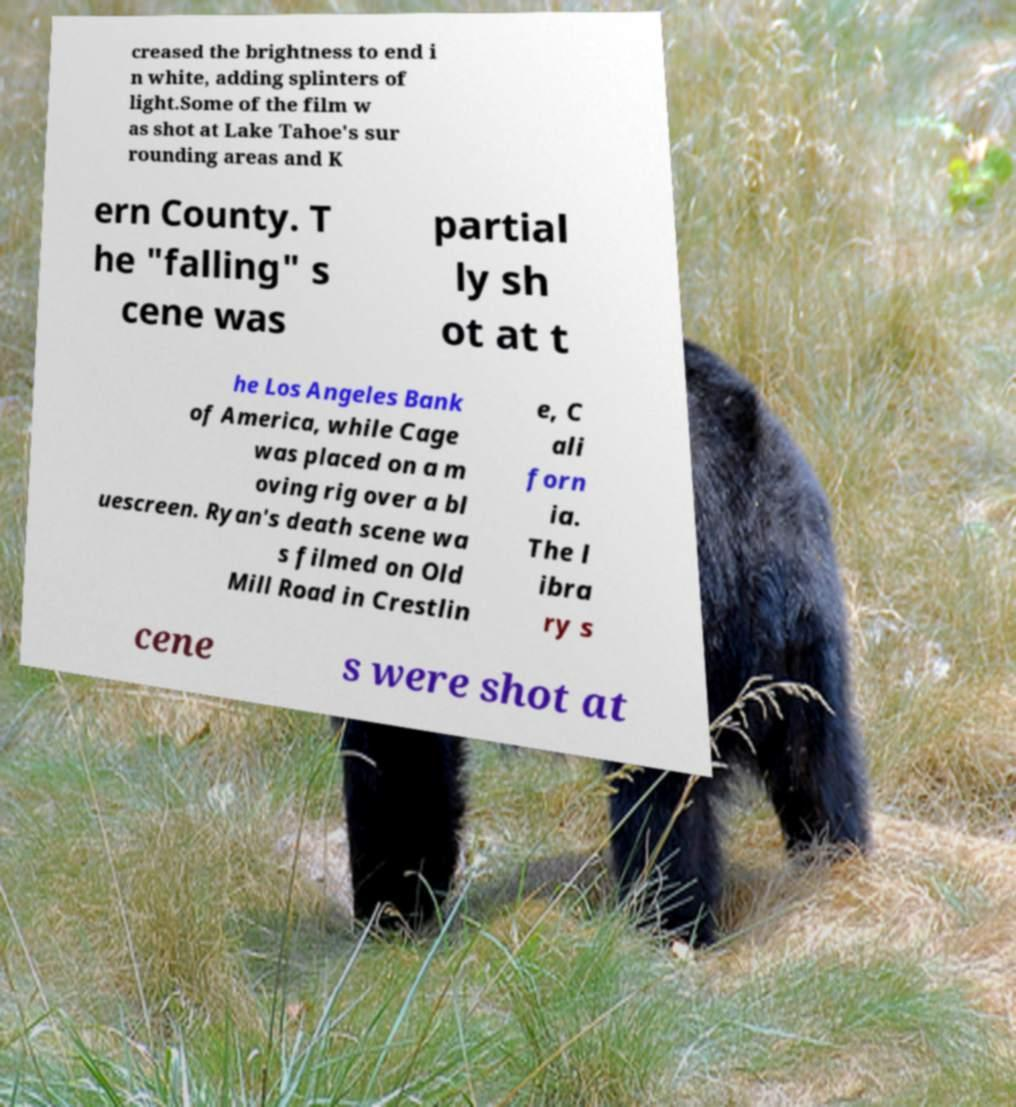There's text embedded in this image that I need extracted. Can you transcribe it verbatim? creased the brightness to end i n white, adding splinters of light.Some of the film w as shot at Lake Tahoe's sur rounding areas and K ern County. T he "falling" s cene was partial ly sh ot at t he Los Angeles Bank of America, while Cage was placed on a m oving rig over a bl uescreen. Ryan's death scene wa s filmed on Old Mill Road in Crestlin e, C ali forn ia. The l ibra ry s cene s were shot at 